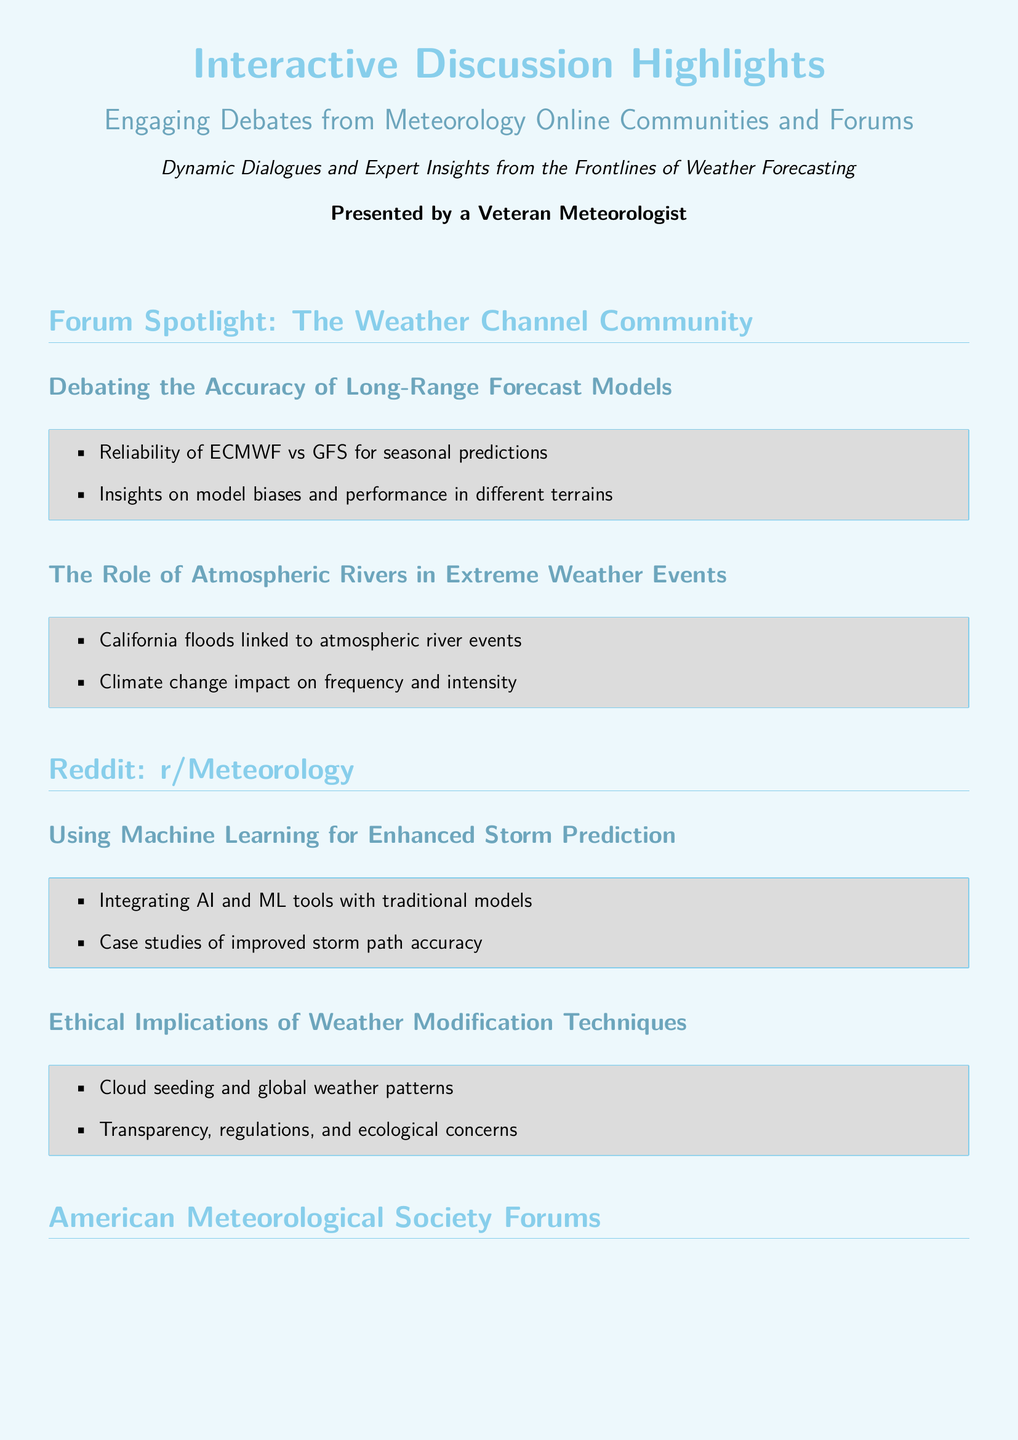What is the title of the document? The title is prominently displayed at the top of the document.
Answer: Interactive Discussion Highlights Who presented the highlights? The document indicates the presenter at the end of the introduction.
Answer: A Veteran Meteorologist What forum is spotlighted in the document? The document specifies the name of the community being highlighted.
Answer: The Weather Channel Community What two forecasting models are compared? The document mentions the models being debated in the first subsection.
Answer: ECMWF vs GFS What is linked to California floods according to the discussion? The document outlines a major extreme weather element in the listed topics.
Answer: Atmospheric river events Which online platform's subreddit is mentioned? The document identifies the platform associated with the second section.
Answer: Reddit: r/Meteorology Name one weather modification technique discussed. The document provides information on ethical discussions regarding a specific technique.
Answer: Cloud seeding What mitigation strategy is suggested for Urban Heat Islands? The document references possible solutions for urban weather impacts.
Answer: Green roofs What is a focus of the American Meteorological Society forums? The document notes the key discussion topics under this subsection.
Answer: Communicating Climate Change to the Public 